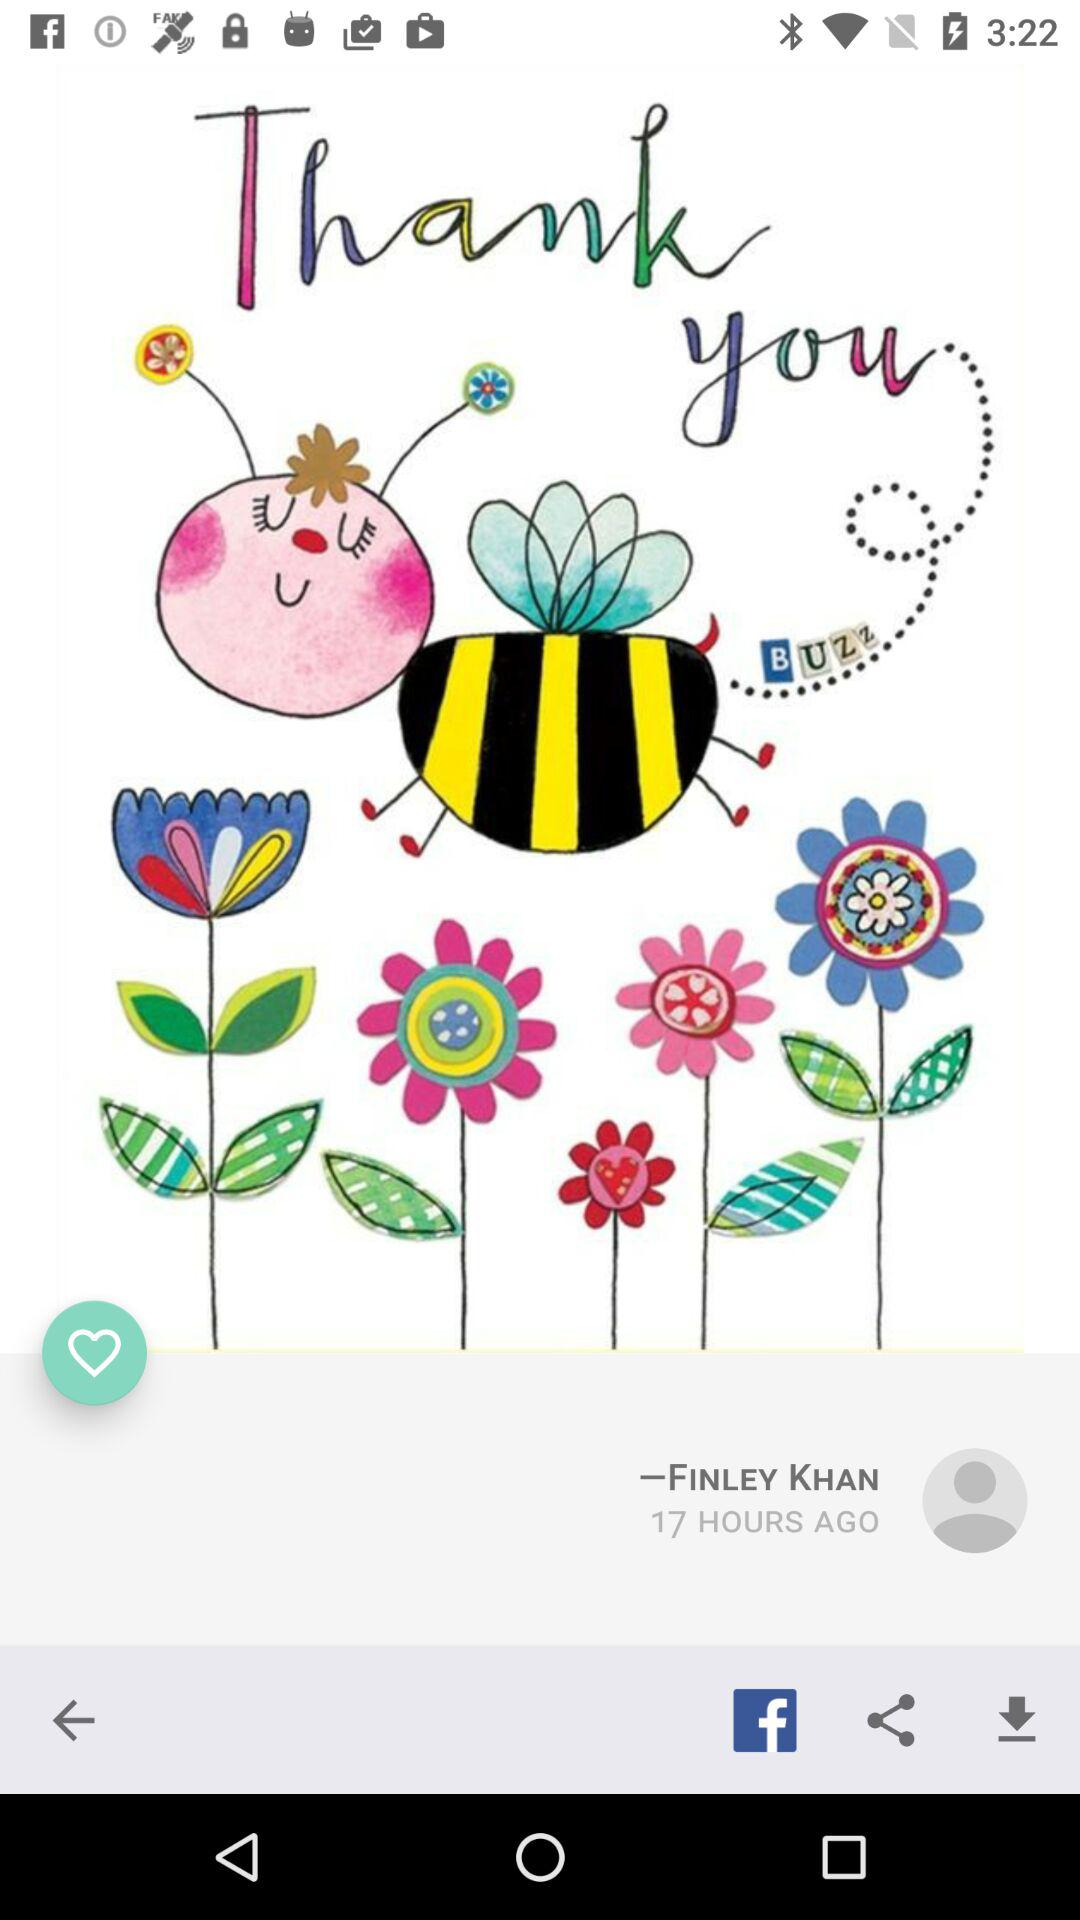When was Finley Khan online? Finley Khan was online 17 hours ago. 